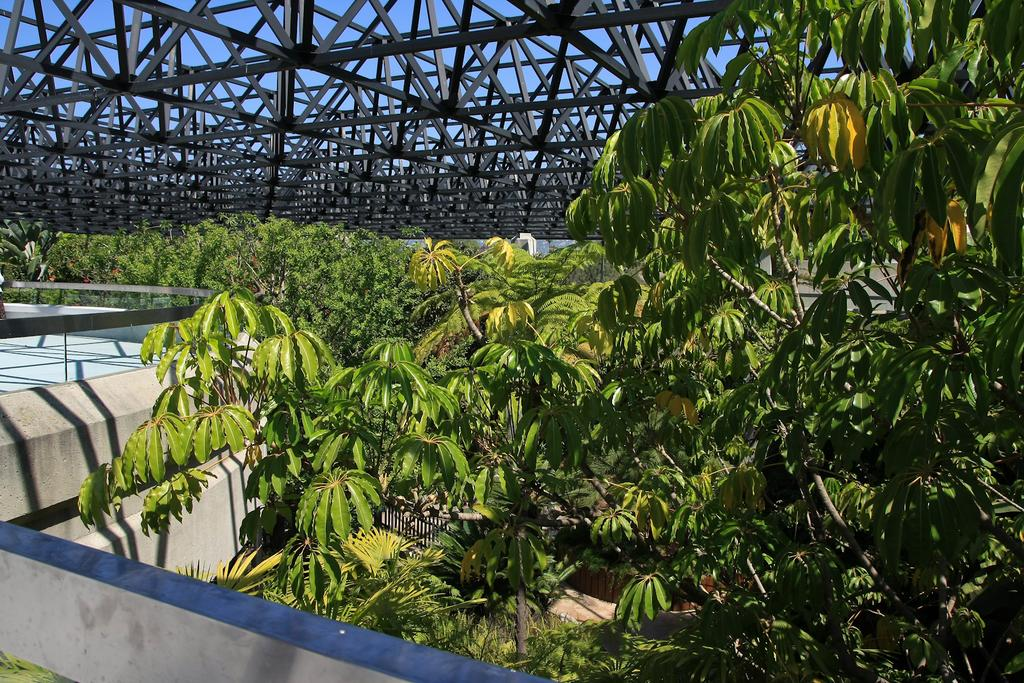What type of vegetation can be seen in the image? There are plants and trees in the image. What color are the plants and trees in the image? The plants and trees are green. What man-made structure is present in the image? There is a bridge in the image. What type of wall can be seen in the image? There is a compound wall in the image. What type of alarm is ringing in the image? There is no alarm present in the image. What additional detail can be seen on the bridge in the image? The provided facts do not mention any specific details about the bridge, so we cannot answer this question. 